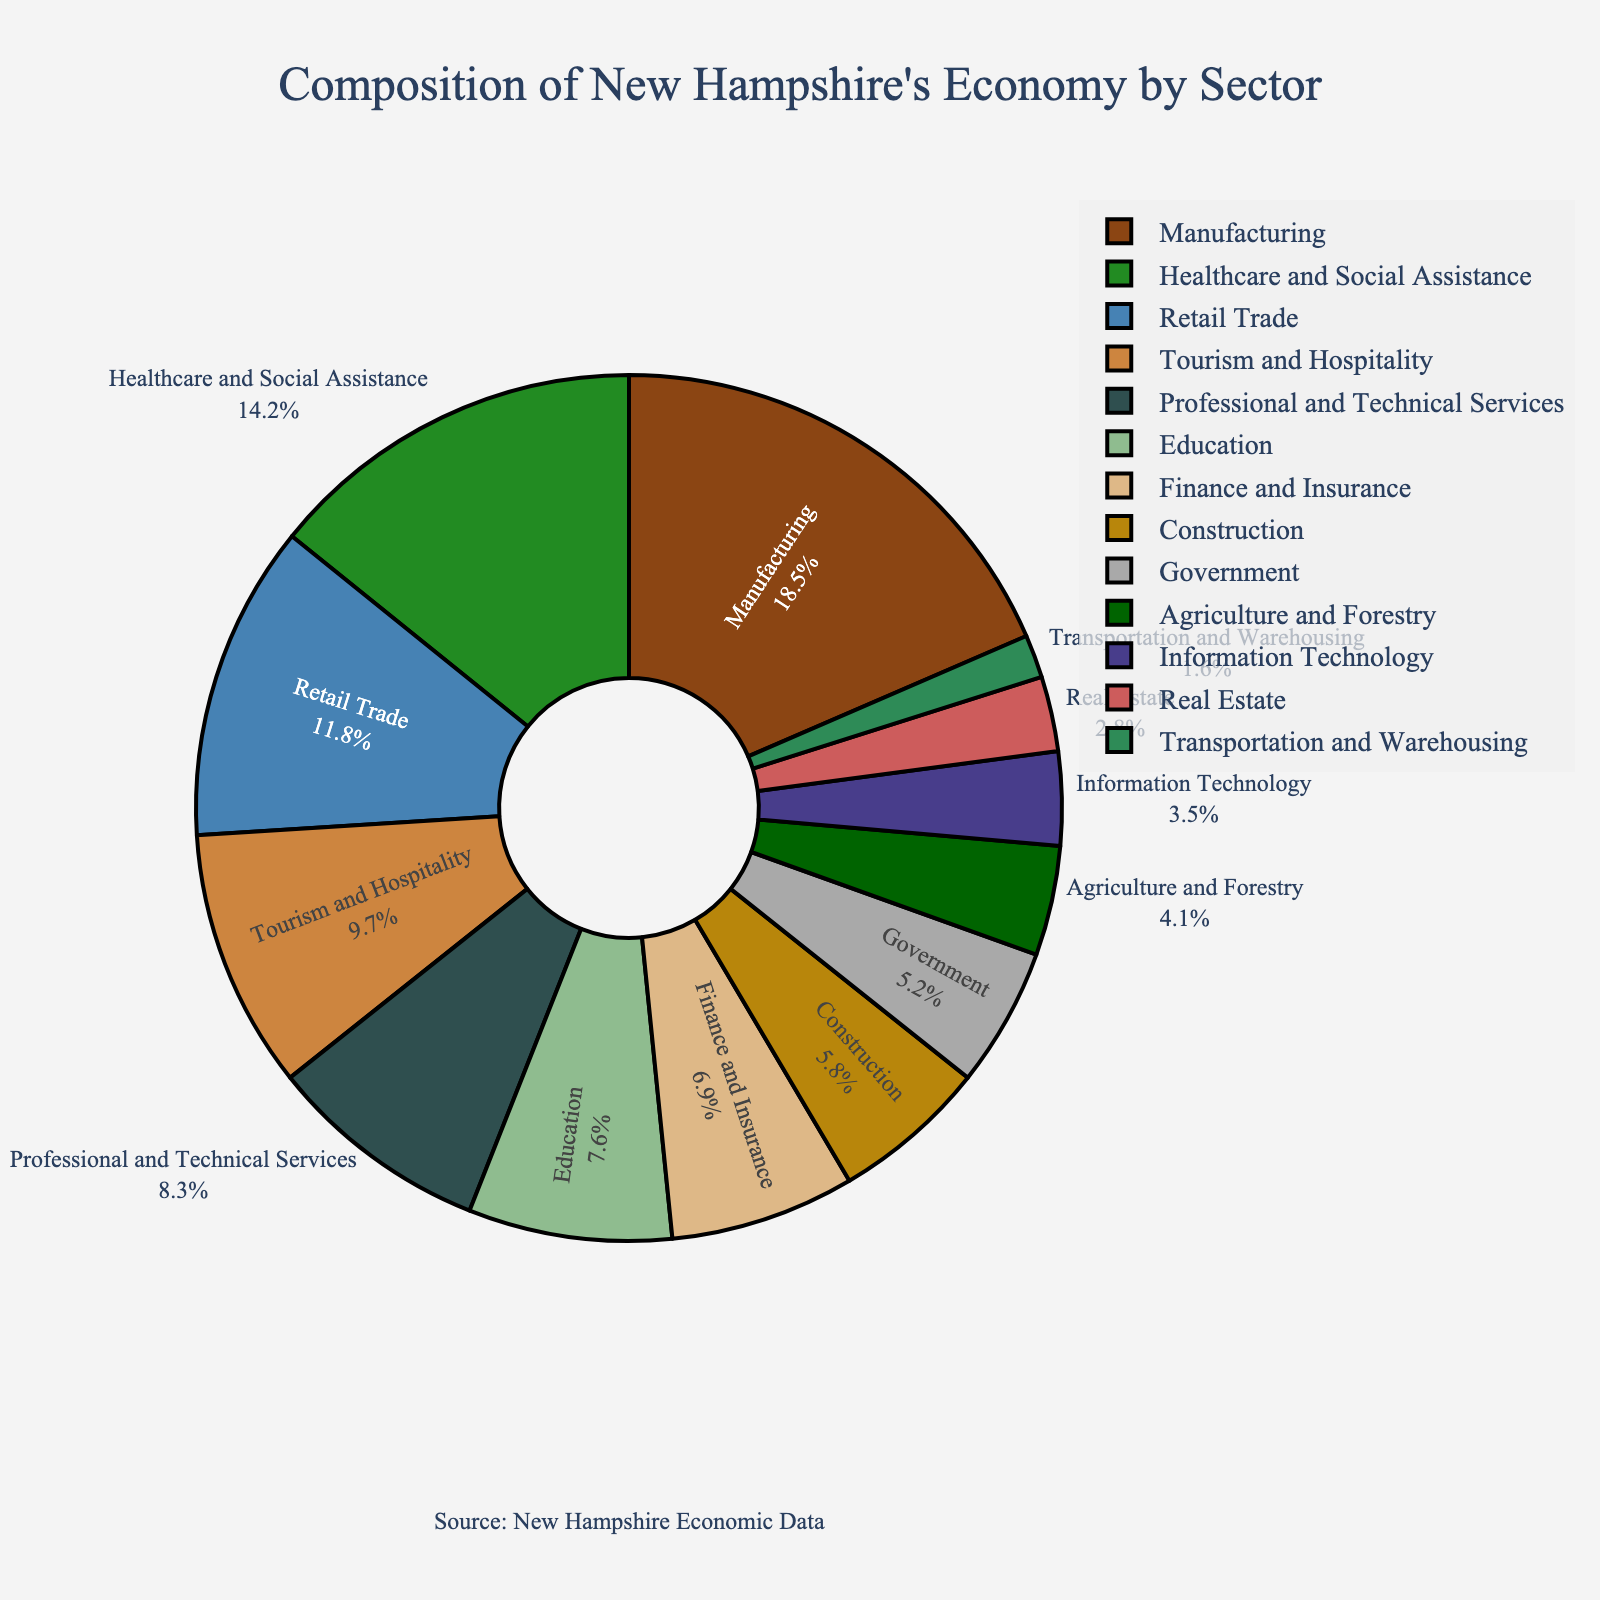what sector has the largest share of New Hampshire's economy? The pie chart indicates the percentage share of different sectors. By checking the percentages, we see that Manufacturing has the highest share at 18.5%.
Answer: Manufacturing What is the combined percentage of Healthcare and Social Assistance and Education sectors? Adding the percentages for Healthcare and Social Assistance (14.2%) and Education (7.6%), we get 14.2 + 7.6 = 21.8%.
Answer: 21.8% How does the percentage of Retail Trade compare to that of Finance and Insurance? The percentage for Retail Trade is 11.8%, whereas for Finance and Insurance it's 6.9%. Therefore, Retail Trade’s contribution is larger.
Answer: Retail Trade is larger Which sector contributes more to New Hampshire's economy: Government or Construction? According to the pie chart, the Government sector contributes 5.2%, while the Construction sector contributes 5.8%. Hence, Construction contributes more.
Answer: Construction Identify the sector with the smallest percentage share and state its percentage. By inspecting the pie chart, Transportation and Warehousing has the smallest share at 1.6%.
Answer: Transportation and Warehousing, 1.6% Is the combined percentage of Tourism and Hospitality greater than that of all Professional and Technical Services? Tourism and Hospitality is at 9.7%. Professional and Technical Services is at 8.3%. Since 9.7% > 8.3%, Tourism and Hospitality contributes more.
Answer: Yes, it is greater What is the total percentage of sectors that individually contribute less than 5% to New Hampshire's economy? Summing the percentages of sectors below 5%: Agriculture and Forestry (4.1%), Information Technology (3.5%), Real Estate (2.8%), Transportation and Warehousing (1.6%). Total: 4.1 + 3.5 + 2.8 + 1.6 = 12%.
Answer: 12% Which sector occupies a share closest to 10%? Tourism and Hospitality has a share of 9.7%, which is closest to 10%.
Answer: Tourism and Hospitality How much more significant is the Manufacturing sector than the Information Technology sector? Manufacturing is at 18.5% and Information Technology is at 3.5%. The difference is 18.5 - 3.5 = 15%.
Answer: 15% Arrange the top five sectors in descending order of their contribution. The top five sectors are Manufacturing (18.5%), Healthcare and Social Assistance (14.2%), Retail Trade (11.8%), Tourism and Hospitality (9.7%), and Professional and Technical Services (8.3%).
Answer: Manufacturing, Healthcare and Social Assistance, Retail Trade, Tourism and Hospitality, Professional and Technical Services 